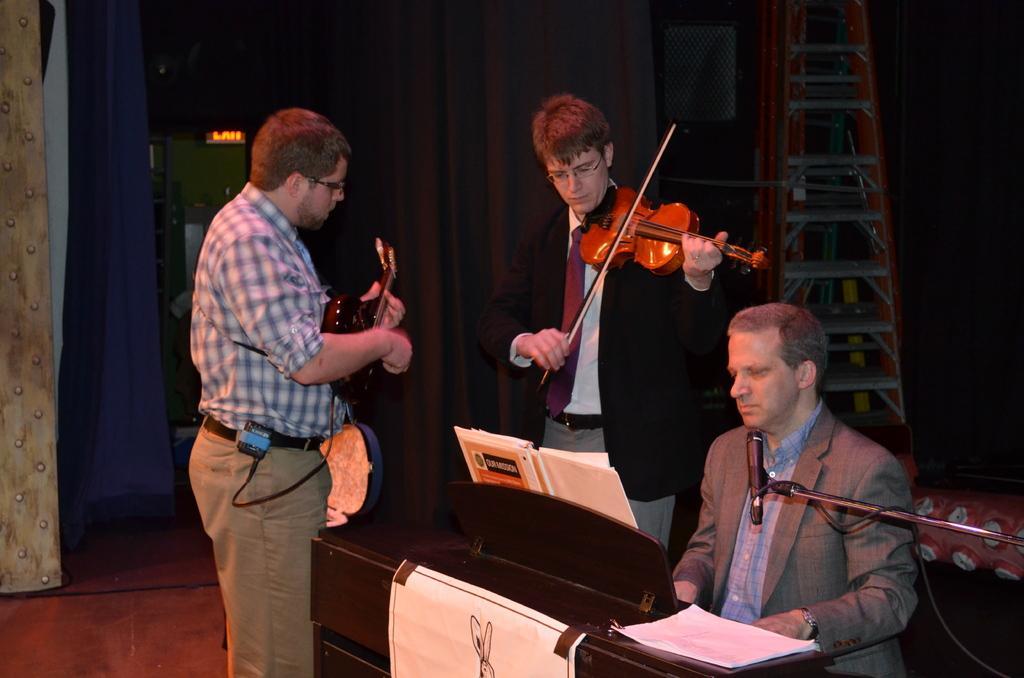Could you give a brief overview of what you see in this image? In the image in the center we can see two people were standing and they were playing violin. On the right side of the image,we can see one person sitting. In front of him,we can see papers,book,table and microphone. In the background there is a wall,ladder,curtain and few other objects. 